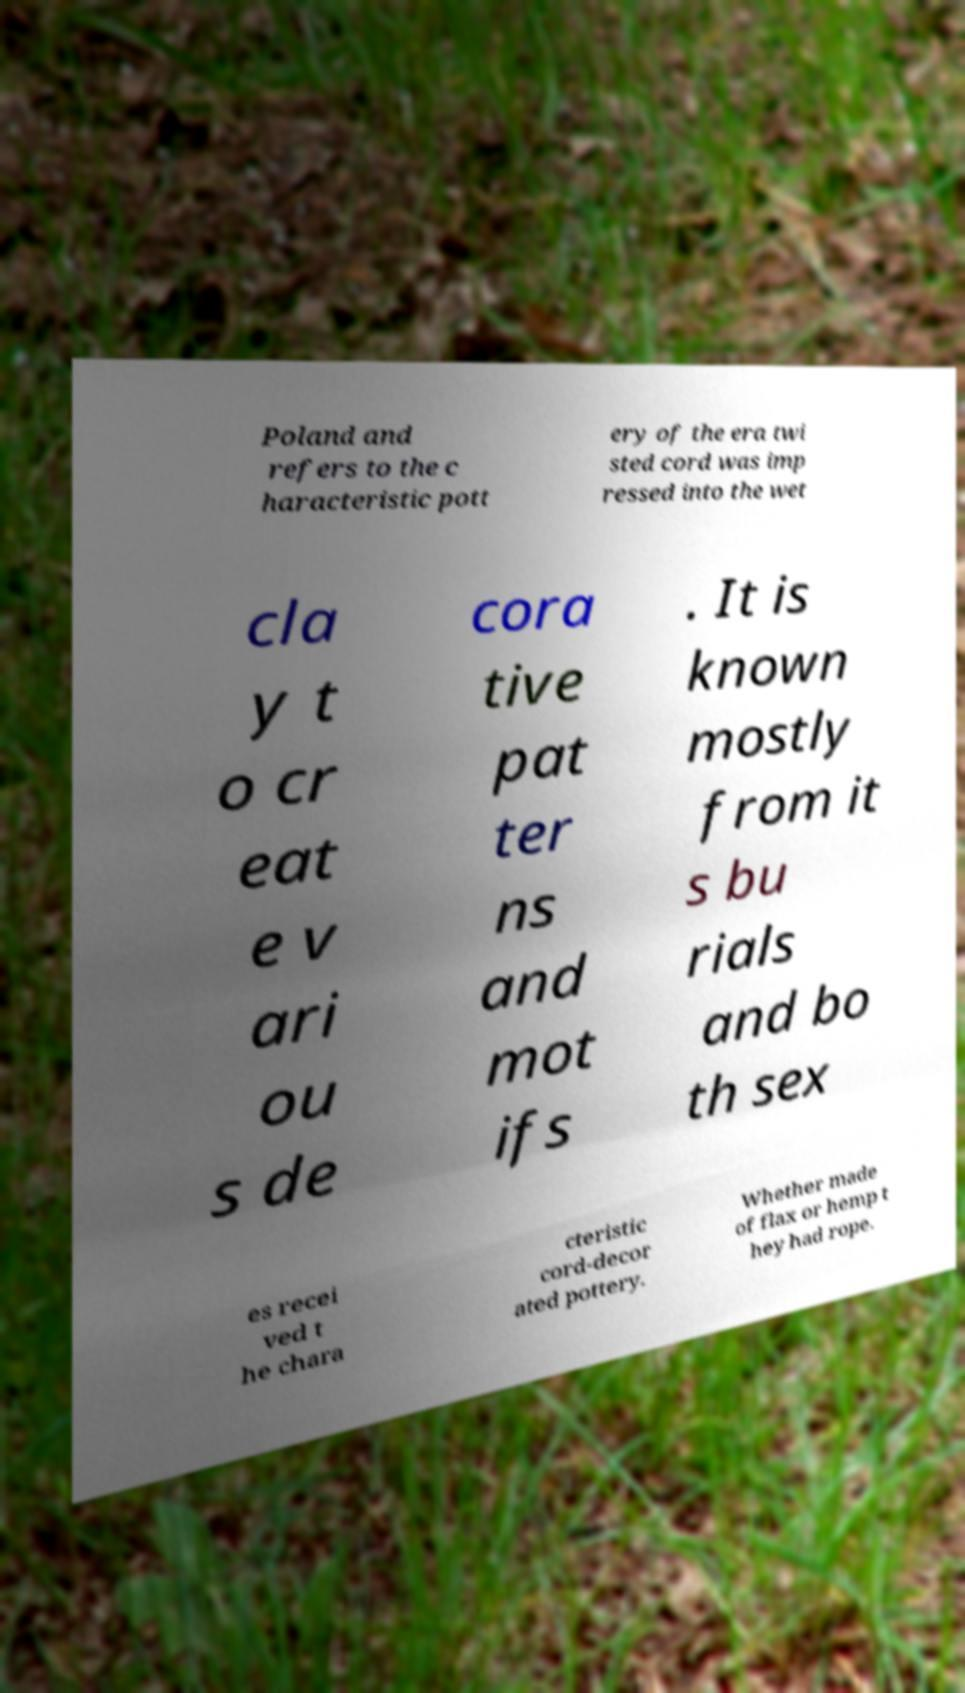What messages or text are displayed in this image? I need them in a readable, typed format. Poland and refers to the c haracteristic pott ery of the era twi sted cord was imp ressed into the wet cla y t o cr eat e v ari ou s de cora tive pat ter ns and mot ifs . It is known mostly from it s bu rials and bo th sex es recei ved t he chara cteristic cord-decor ated pottery. Whether made of flax or hemp t hey had rope. 